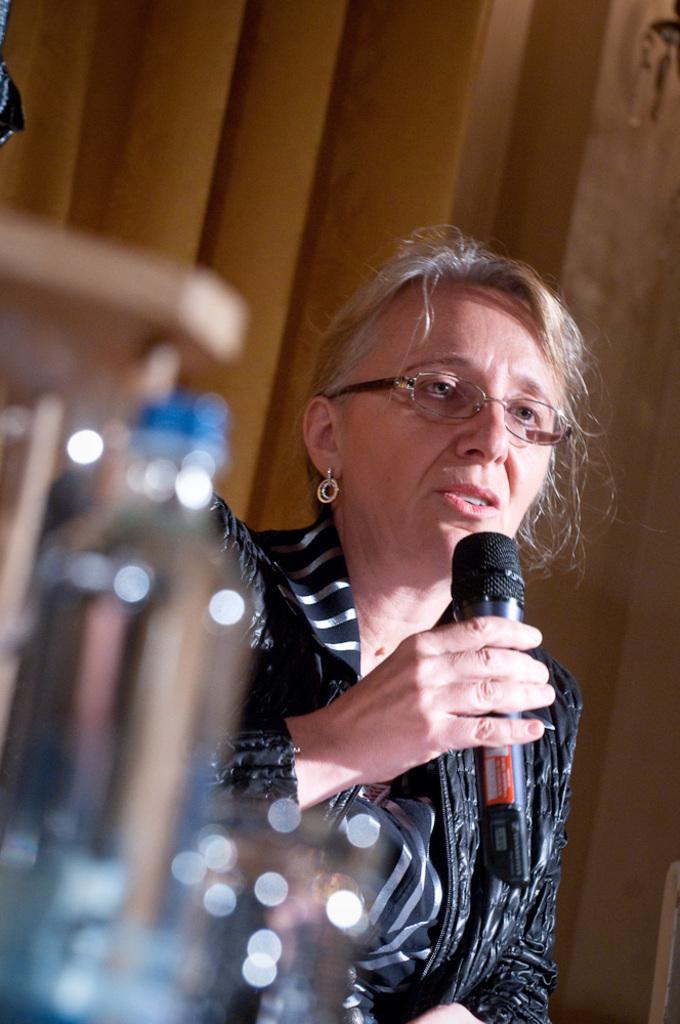Could you give a brief overview of what you see in this image? In this image there is a woman who is holding the mic with her hand and in front of her there is a bottle. At the background there is a curtain. 